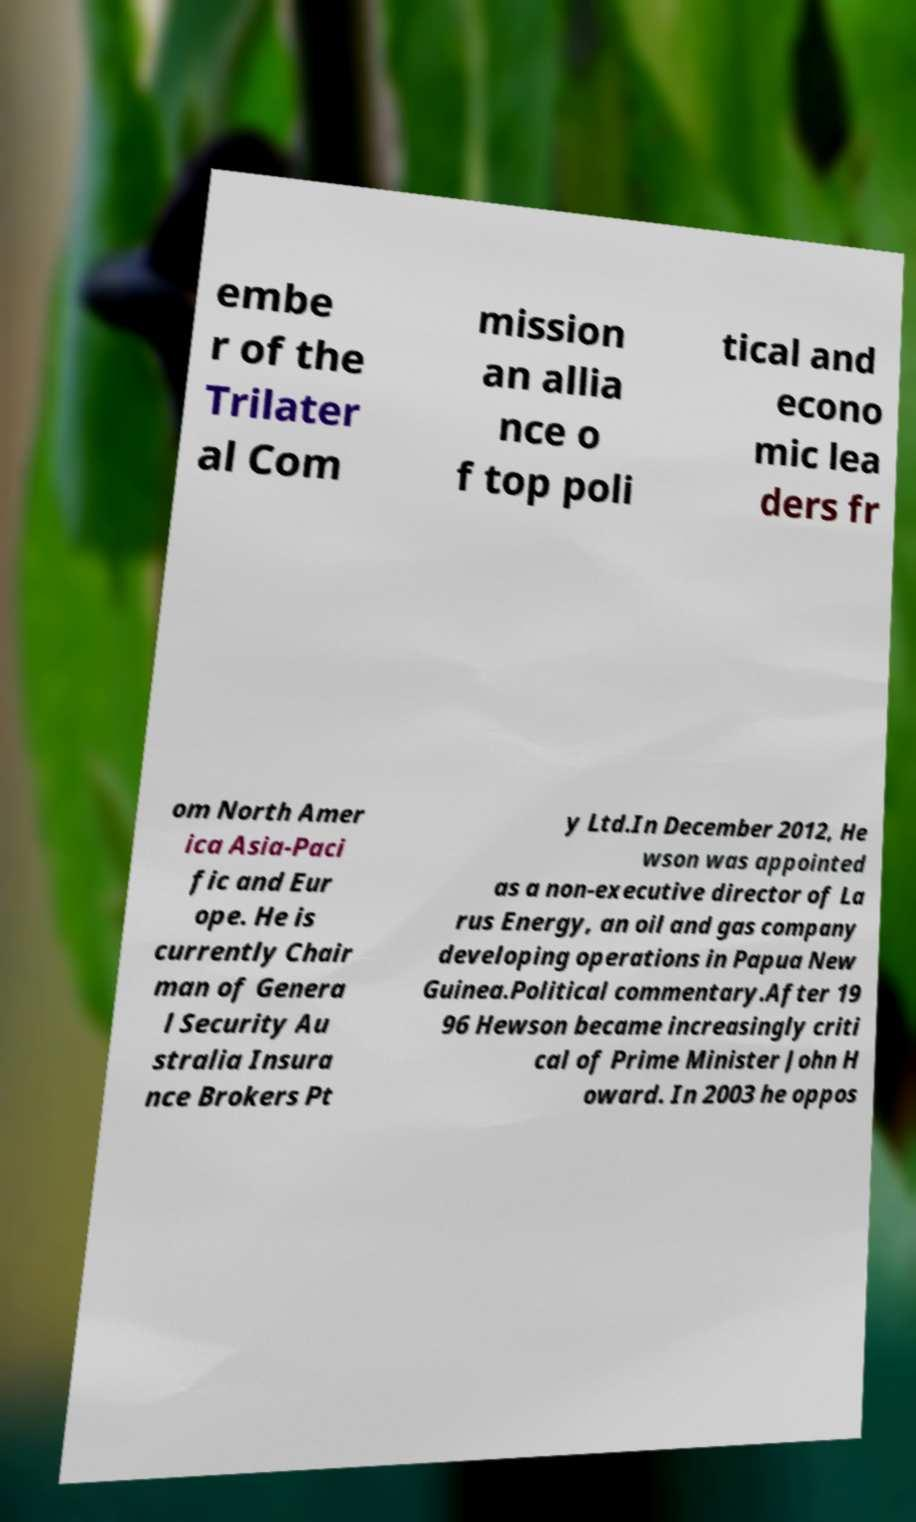Can you read and provide the text displayed in the image?This photo seems to have some interesting text. Can you extract and type it out for me? embe r of the Trilater al Com mission an allia nce o f top poli tical and econo mic lea ders fr om North Amer ica Asia-Paci fic and Eur ope. He is currently Chair man of Genera l Security Au stralia Insura nce Brokers Pt y Ltd.In December 2012, He wson was appointed as a non-executive director of La rus Energy, an oil and gas company developing operations in Papua New Guinea.Political commentary.After 19 96 Hewson became increasingly criti cal of Prime Minister John H oward. In 2003 he oppos 